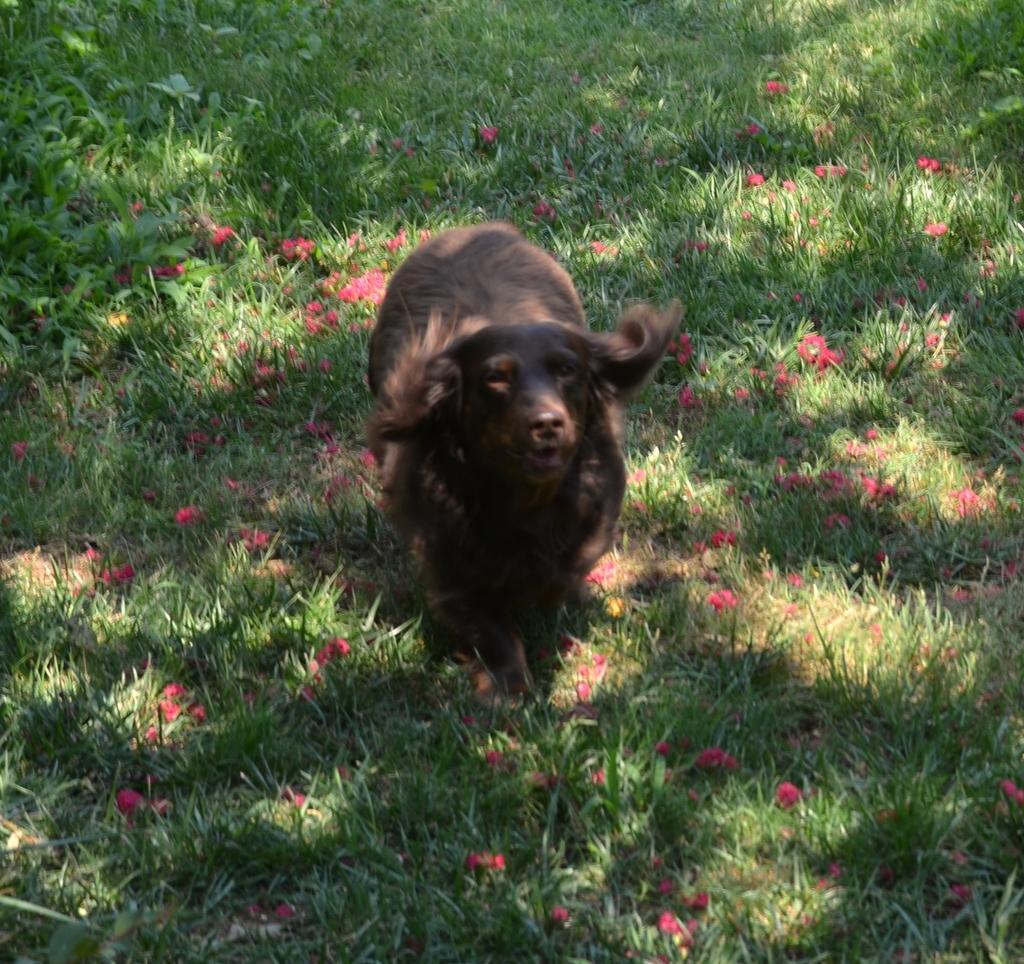What type of creature is in the image? There is an animal in the image. Where is the animal located? The animal is on the ground. What color is the animal? The animal is brown in color. What type of vegetation is present in the image? There is grass in the image. What other colorful elements can be seen in the image? There are pink flowers in the image. What type of pipe is being used by the animal in the image? There is no pipe present in the image; the animal is simply on the ground. 